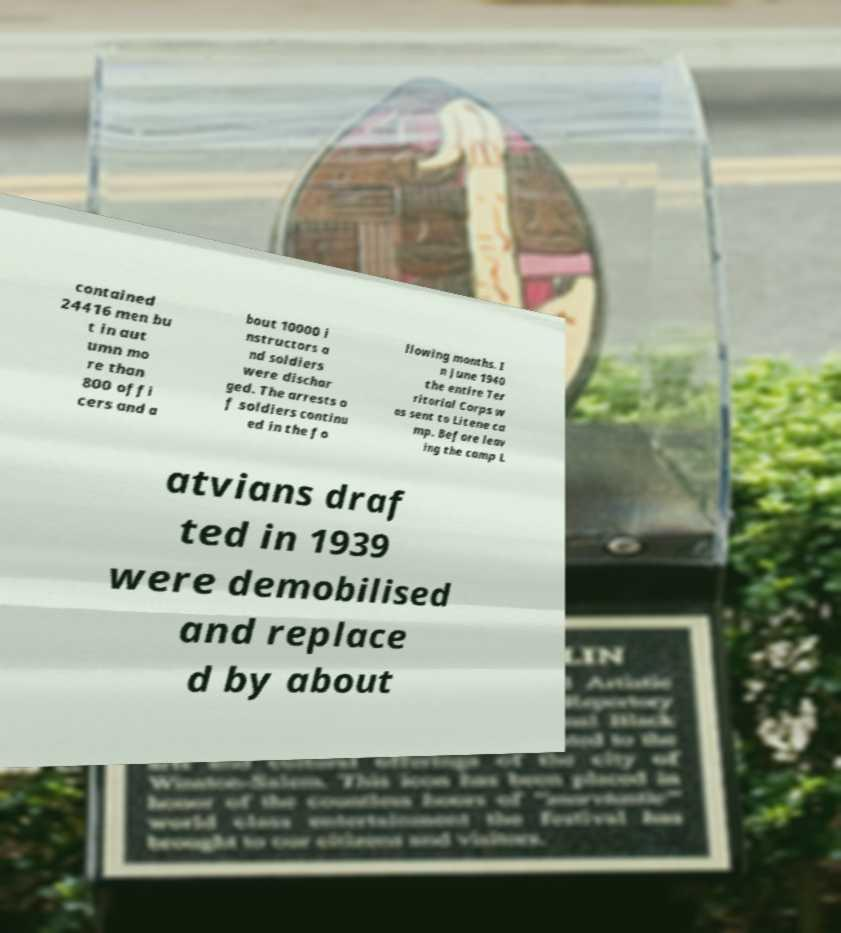Can you read and provide the text displayed in the image?This photo seems to have some interesting text. Can you extract and type it out for me? contained 24416 men bu t in aut umn mo re than 800 offi cers and a bout 10000 i nstructors a nd soldiers were dischar ged. The arrests o f soldiers continu ed in the fo llowing months. I n June 1940 the entire Ter ritorial Corps w as sent to Litene ca mp. Before leav ing the camp L atvians draf ted in 1939 were demobilised and replace d by about 